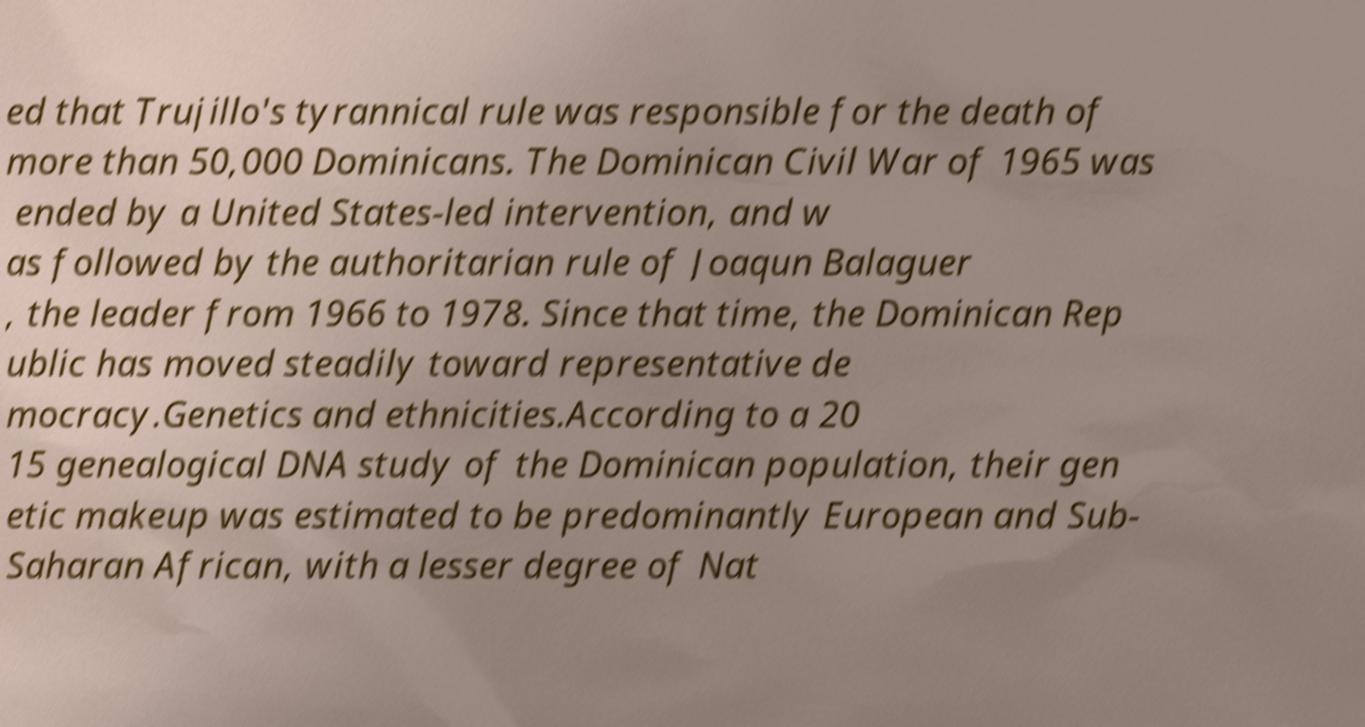Can you read and provide the text displayed in the image?This photo seems to have some interesting text. Can you extract and type it out for me? ed that Trujillo's tyrannical rule was responsible for the death of more than 50,000 Dominicans. The Dominican Civil War of 1965 was ended by a United States-led intervention, and w as followed by the authoritarian rule of Joaqun Balaguer , the leader from 1966 to 1978. Since that time, the Dominican Rep ublic has moved steadily toward representative de mocracy.Genetics and ethnicities.According to a 20 15 genealogical DNA study of the Dominican population, their gen etic makeup was estimated to be predominantly European and Sub- Saharan African, with a lesser degree of Nat 